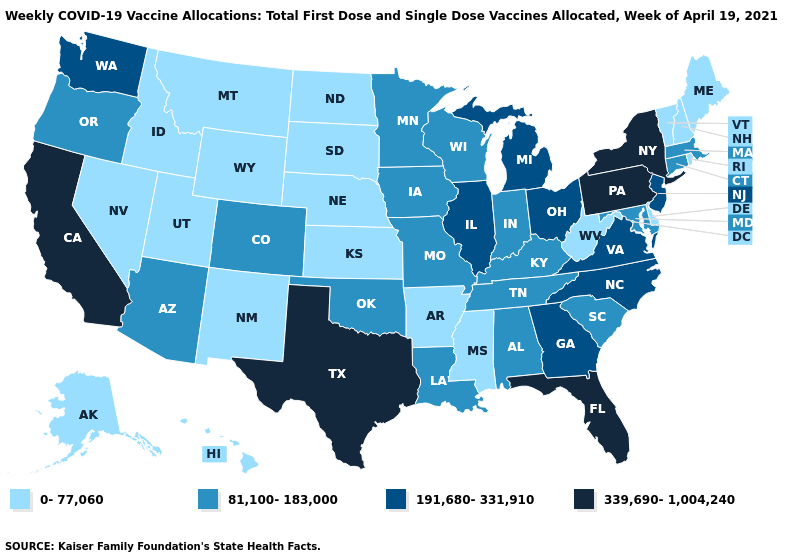Name the states that have a value in the range 0-77,060?
Short answer required. Alaska, Arkansas, Delaware, Hawaii, Idaho, Kansas, Maine, Mississippi, Montana, Nebraska, Nevada, New Hampshire, New Mexico, North Dakota, Rhode Island, South Dakota, Utah, Vermont, West Virginia, Wyoming. What is the lowest value in the MidWest?
Give a very brief answer. 0-77,060. Among the states that border Arkansas , does Texas have the highest value?
Concise answer only. Yes. What is the value of Florida?
Concise answer only. 339,690-1,004,240. Name the states that have a value in the range 339,690-1,004,240?
Keep it brief. California, Florida, New York, Pennsylvania, Texas. What is the value of Hawaii?
Write a very short answer. 0-77,060. Which states hav the highest value in the South?
Keep it brief. Florida, Texas. Which states have the highest value in the USA?
Quick response, please. California, Florida, New York, Pennsylvania, Texas. Among the states that border Nevada , which have the highest value?
Concise answer only. California. Does Pennsylvania have the highest value in the USA?
Concise answer only. Yes. Name the states that have a value in the range 0-77,060?
Quick response, please. Alaska, Arkansas, Delaware, Hawaii, Idaho, Kansas, Maine, Mississippi, Montana, Nebraska, Nevada, New Hampshire, New Mexico, North Dakota, Rhode Island, South Dakota, Utah, Vermont, West Virginia, Wyoming. What is the value of Georgia?
Keep it brief. 191,680-331,910. What is the value of North Carolina?
Give a very brief answer. 191,680-331,910. Does the map have missing data?
Keep it brief. No. Which states have the lowest value in the Northeast?
Keep it brief. Maine, New Hampshire, Rhode Island, Vermont. 